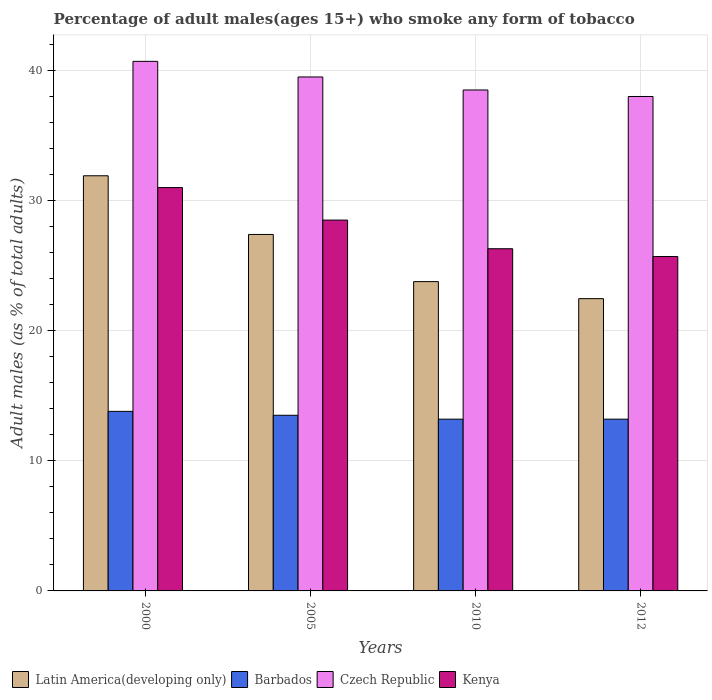Are the number of bars on each tick of the X-axis equal?
Make the answer very short. Yes. What is the label of the 1st group of bars from the left?
Your response must be concise. 2000. In how many cases, is the number of bars for a given year not equal to the number of legend labels?
Offer a very short reply. 0. What is the percentage of adult males who smoke in Latin America(developing only) in 2005?
Keep it short and to the point. 27.4. Across all years, what is the maximum percentage of adult males who smoke in Latin America(developing only)?
Provide a short and direct response. 31.91. Across all years, what is the minimum percentage of adult males who smoke in Kenya?
Make the answer very short. 25.7. In which year was the percentage of adult males who smoke in Latin America(developing only) maximum?
Your answer should be very brief. 2000. What is the total percentage of adult males who smoke in Latin America(developing only) in the graph?
Offer a terse response. 105.54. What is the difference between the percentage of adult males who smoke in Latin America(developing only) in 2000 and that in 2010?
Make the answer very short. 8.13. What is the difference between the percentage of adult males who smoke in Czech Republic in 2000 and the percentage of adult males who smoke in Kenya in 2010?
Your response must be concise. 14.4. What is the average percentage of adult males who smoke in Czech Republic per year?
Your response must be concise. 39.17. In the year 2000, what is the difference between the percentage of adult males who smoke in Czech Republic and percentage of adult males who smoke in Kenya?
Your answer should be very brief. 9.7. In how many years, is the percentage of adult males who smoke in Barbados greater than 36 %?
Provide a short and direct response. 0. What is the ratio of the percentage of adult males who smoke in Barbados in 2005 to that in 2012?
Keep it short and to the point. 1.02. Is the percentage of adult males who smoke in Latin America(developing only) in 2000 less than that in 2012?
Make the answer very short. No. What is the difference between the highest and the second highest percentage of adult males who smoke in Barbados?
Make the answer very short. 0.3. What is the difference between the highest and the lowest percentage of adult males who smoke in Kenya?
Make the answer very short. 5.3. In how many years, is the percentage of adult males who smoke in Barbados greater than the average percentage of adult males who smoke in Barbados taken over all years?
Make the answer very short. 2. Is the sum of the percentage of adult males who smoke in Latin America(developing only) in 2000 and 2005 greater than the maximum percentage of adult males who smoke in Barbados across all years?
Your answer should be compact. Yes. Is it the case that in every year, the sum of the percentage of adult males who smoke in Kenya and percentage of adult males who smoke in Czech Republic is greater than the sum of percentage of adult males who smoke in Barbados and percentage of adult males who smoke in Latin America(developing only)?
Your response must be concise. Yes. What does the 2nd bar from the left in 2005 represents?
Give a very brief answer. Barbados. What does the 2nd bar from the right in 2010 represents?
Provide a short and direct response. Czech Republic. How many bars are there?
Offer a terse response. 16. Are all the bars in the graph horizontal?
Offer a very short reply. No. How many years are there in the graph?
Ensure brevity in your answer.  4. What is the title of the graph?
Give a very brief answer. Percentage of adult males(ages 15+) who smoke any form of tobacco. What is the label or title of the Y-axis?
Give a very brief answer. Adult males (as % of total adults). What is the Adult males (as % of total adults) in Latin America(developing only) in 2000?
Provide a succinct answer. 31.91. What is the Adult males (as % of total adults) in Czech Republic in 2000?
Provide a succinct answer. 40.7. What is the Adult males (as % of total adults) in Latin America(developing only) in 2005?
Offer a very short reply. 27.4. What is the Adult males (as % of total adults) of Barbados in 2005?
Your answer should be compact. 13.5. What is the Adult males (as % of total adults) in Czech Republic in 2005?
Provide a short and direct response. 39.5. What is the Adult males (as % of total adults) of Kenya in 2005?
Provide a succinct answer. 28.5. What is the Adult males (as % of total adults) of Latin America(developing only) in 2010?
Offer a very short reply. 23.77. What is the Adult males (as % of total adults) of Czech Republic in 2010?
Offer a terse response. 38.5. What is the Adult males (as % of total adults) of Kenya in 2010?
Offer a very short reply. 26.3. What is the Adult males (as % of total adults) of Latin America(developing only) in 2012?
Provide a succinct answer. 22.46. What is the Adult males (as % of total adults) in Kenya in 2012?
Your answer should be compact. 25.7. Across all years, what is the maximum Adult males (as % of total adults) of Latin America(developing only)?
Make the answer very short. 31.91. Across all years, what is the maximum Adult males (as % of total adults) of Barbados?
Provide a succinct answer. 13.8. Across all years, what is the maximum Adult males (as % of total adults) of Czech Republic?
Provide a succinct answer. 40.7. Across all years, what is the minimum Adult males (as % of total adults) in Latin America(developing only)?
Keep it short and to the point. 22.46. Across all years, what is the minimum Adult males (as % of total adults) of Kenya?
Your answer should be very brief. 25.7. What is the total Adult males (as % of total adults) in Latin America(developing only) in the graph?
Provide a succinct answer. 105.54. What is the total Adult males (as % of total adults) in Barbados in the graph?
Provide a succinct answer. 53.7. What is the total Adult males (as % of total adults) of Czech Republic in the graph?
Offer a very short reply. 156.7. What is the total Adult males (as % of total adults) in Kenya in the graph?
Give a very brief answer. 111.5. What is the difference between the Adult males (as % of total adults) in Latin America(developing only) in 2000 and that in 2005?
Your answer should be very brief. 4.51. What is the difference between the Adult males (as % of total adults) in Barbados in 2000 and that in 2005?
Make the answer very short. 0.3. What is the difference between the Adult males (as % of total adults) in Kenya in 2000 and that in 2005?
Ensure brevity in your answer.  2.5. What is the difference between the Adult males (as % of total adults) of Latin America(developing only) in 2000 and that in 2010?
Offer a very short reply. 8.13. What is the difference between the Adult males (as % of total adults) of Barbados in 2000 and that in 2010?
Offer a terse response. 0.6. What is the difference between the Adult males (as % of total adults) of Czech Republic in 2000 and that in 2010?
Your response must be concise. 2.2. What is the difference between the Adult males (as % of total adults) of Kenya in 2000 and that in 2010?
Ensure brevity in your answer.  4.7. What is the difference between the Adult males (as % of total adults) in Latin America(developing only) in 2000 and that in 2012?
Offer a terse response. 9.44. What is the difference between the Adult males (as % of total adults) in Latin America(developing only) in 2005 and that in 2010?
Ensure brevity in your answer.  3.62. What is the difference between the Adult males (as % of total adults) of Latin America(developing only) in 2005 and that in 2012?
Ensure brevity in your answer.  4.93. What is the difference between the Adult males (as % of total adults) in Barbados in 2005 and that in 2012?
Ensure brevity in your answer.  0.3. What is the difference between the Adult males (as % of total adults) in Kenya in 2005 and that in 2012?
Your response must be concise. 2.8. What is the difference between the Adult males (as % of total adults) of Latin America(developing only) in 2010 and that in 2012?
Give a very brief answer. 1.31. What is the difference between the Adult males (as % of total adults) in Barbados in 2010 and that in 2012?
Offer a terse response. 0. What is the difference between the Adult males (as % of total adults) of Latin America(developing only) in 2000 and the Adult males (as % of total adults) of Barbados in 2005?
Provide a succinct answer. 18.41. What is the difference between the Adult males (as % of total adults) of Latin America(developing only) in 2000 and the Adult males (as % of total adults) of Czech Republic in 2005?
Make the answer very short. -7.59. What is the difference between the Adult males (as % of total adults) in Latin America(developing only) in 2000 and the Adult males (as % of total adults) in Kenya in 2005?
Your answer should be compact. 3.41. What is the difference between the Adult males (as % of total adults) of Barbados in 2000 and the Adult males (as % of total adults) of Czech Republic in 2005?
Ensure brevity in your answer.  -25.7. What is the difference between the Adult males (as % of total adults) of Barbados in 2000 and the Adult males (as % of total adults) of Kenya in 2005?
Provide a short and direct response. -14.7. What is the difference between the Adult males (as % of total adults) in Czech Republic in 2000 and the Adult males (as % of total adults) in Kenya in 2005?
Keep it short and to the point. 12.2. What is the difference between the Adult males (as % of total adults) of Latin America(developing only) in 2000 and the Adult males (as % of total adults) of Barbados in 2010?
Give a very brief answer. 18.71. What is the difference between the Adult males (as % of total adults) of Latin America(developing only) in 2000 and the Adult males (as % of total adults) of Czech Republic in 2010?
Your response must be concise. -6.59. What is the difference between the Adult males (as % of total adults) of Latin America(developing only) in 2000 and the Adult males (as % of total adults) of Kenya in 2010?
Your answer should be compact. 5.61. What is the difference between the Adult males (as % of total adults) of Barbados in 2000 and the Adult males (as % of total adults) of Czech Republic in 2010?
Your response must be concise. -24.7. What is the difference between the Adult males (as % of total adults) in Barbados in 2000 and the Adult males (as % of total adults) in Kenya in 2010?
Your answer should be very brief. -12.5. What is the difference between the Adult males (as % of total adults) of Czech Republic in 2000 and the Adult males (as % of total adults) of Kenya in 2010?
Offer a terse response. 14.4. What is the difference between the Adult males (as % of total adults) of Latin America(developing only) in 2000 and the Adult males (as % of total adults) of Barbados in 2012?
Your answer should be compact. 18.71. What is the difference between the Adult males (as % of total adults) of Latin America(developing only) in 2000 and the Adult males (as % of total adults) of Czech Republic in 2012?
Keep it short and to the point. -6.09. What is the difference between the Adult males (as % of total adults) in Latin America(developing only) in 2000 and the Adult males (as % of total adults) in Kenya in 2012?
Provide a succinct answer. 6.21. What is the difference between the Adult males (as % of total adults) in Barbados in 2000 and the Adult males (as % of total adults) in Czech Republic in 2012?
Give a very brief answer. -24.2. What is the difference between the Adult males (as % of total adults) in Latin America(developing only) in 2005 and the Adult males (as % of total adults) in Barbados in 2010?
Offer a terse response. 14.2. What is the difference between the Adult males (as % of total adults) in Latin America(developing only) in 2005 and the Adult males (as % of total adults) in Czech Republic in 2010?
Offer a very short reply. -11.1. What is the difference between the Adult males (as % of total adults) of Latin America(developing only) in 2005 and the Adult males (as % of total adults) of Kenya in 2010?
Provide a short and direct response. 1.1. What is the difference between the Adult males (as % of total adults) of Czech Republic in 2005 and the Adult males (as % of total adults) of Kenya in 2010?
Keep it short and to the point. 13.2. What is the difference between the Adult males (as % of total adults) in Latin America(developing only) in 2005 and the Adult males (as % of total adults) in Barbados in 2012?
Give a very brief answer. 14.2. What is the difference between the Adult males (as % of total adults) of Latin America(developing only) in 2005 and the Adult males (as % of total adults) of Czech Republic in 2012?
Your answer should be very brief. -10.6. What is the difference between the Adult males (as % of total adults) in Latin America(developing only) in 2005 and the Adult males (as % of total adults) in Kenya in 2012?
Ensure brevity in your answer.  1.7. What is the difference between the Adult males (as % of total adults) of Barbados in 2005 and the Adult males (as % of total adults) of Czech Republic in 2012?
Make the answer very short. -24.5. What is the difference between the Adult males (as % of total adults) of Barbados in 2005 and the Adult males (as % of total adults) of Kenya in 2012?
Your answer should be very brief. -12.2. What is the difference between the Adult males (as % of total adults) in Czech Republic in 2005 and the Adult males (as % of total adults) in Kenya in 2012?
Your answer should be very brief. 13.8. What is the difference between the Adult males (as % of total adults) of Latin America(developing only) in 2010 and the Adult males (as % of total adults) of Barbados in 2012?
Your answer should be compact. 10.57. What is the difference between the Adult males (as % of total adults) in Latin America(developing only) in 2010 and the Adult males (as % of total adults) in Czech Republic in 2012?
Your answer should be very brief. -14.23. What is the difference between the Adult males (as % of total adults) of Latin America(developing only) in 2010 and the Adult males (as % of total adults) of Kenya in 2012?
Offer a terse response. -1.93. What is the difference between the Adult males (as % of total adults) in Barbados in 2010 and the Adult males (as % of total adults) in Czech Republic in 2012?
Offer a very short reply. -24.8. What is the difference between the Adult males (as % of total adults) in Barbados in 2010 and the Adult males (as % of total adults) in Kenya in 2012?
Your answer should be very brief. -12.5. What is the difference between the Adult males (as % of total adults) of Czech Republic in 2010 and the Adult males (as % of total adults) of Kenya in 2012?
Offer a very short reply. 12.8. What is the average Adult males (as % of total adults) in Latin America(developing only) per year?
Make the answer very short. 26.38. What is the average Adult males (as % of total adults) of Barbados per year?
Give a very brief answer. 13.43. What is the average Adult males (as % of total adults) in Czech Republic per year?
Your answer should be compact. 39.17. What is the average Adult males (as % of total adults) of Kenya per year?
Ensure brevity in your answer.  27.88. In the year 2000, what is the difference between the Adult males (as % of total adults) in Latin America(developing only) and Adult males (as % of total adults) in Barbados?
Offer a very short reply. 18.11. In the year 2000, what is the difference between the Adult males (as % of total adults) in Latin America(developing only) and Adult males (as % of total adults) in Czech Republic?
Your response must be concise. -8.79. In the year 2000, what is the difference between the Adult males (as % of total adults) in Latin America(developing only) and Adult males (as % of total adults) in Kenya?
Offer a very short reply. 0.91. In the year 2000, what is the difference between the Adult males (as % of total adults) in Barbados and Adult males (as % of total adults) in Czech Republic?
Provide a short and direct response. -26.9. In the year 2000, what is the difference between the Adult males (as % of total adults) in Barbados and Adult males (as % of total adults) in Kenya?
Your answer should be very brief. -17.2. In the year 2005, what is the difference between the Adult males (as % of total adults) of Latin America(developing only) and Adult males (as % of total adults) of Barbados?
Offer a terse response. 13.9. In the year 2005, what is the difference between the Adult males (as % of total adults) of Latin America(developing only) and Adult males (as % of total adults) of Czech Republic?
Provide a short and direct response. -12.1. In the year 2005, what is the difference between the Adult males (as % of total adults) of Latin America(developing only) and Adult males (as % of total adults) of Kenya?
Provide a succinct answer. -1.1. In the year 2005, what is the difference between the Adult males (as % of total adults) in Czech Republic and Adult males (as % of total adults) in Kenya?
Your answer should be very brief. 11. In the year 2010, what is the difference between the Adult males (as % of total adults) of Latin America(developing only) and Adult males (as % of total adults) of Barbados?
Your answer should be compact. 10.57. In the year 2010, what is the difference between the Adult males (as % of total adults) in Latin America(developing only) and Adult males (as % of total adults) in Czech Republic?
Your answer should be very brief. -14.73. In the year 2010, what is the difference between the Adult males (as % of total adults) of Latin America(developing only) and Adult males (as % of total adults) of Kenya?
Your answer should be very brief. -2.53. In the year 2010, what is the difference between the Adult males (as % of total adults) in Barbados and Adult males (as % of total adults) in Czech Republic?
Offer a terse response. -25.3. In the year 2010, what is the difference between the Adult males (as % of total adults) in Barbados and Adult males (as % of total adults) in Kenya?
Your answer should be compact. -13.1. In the year 2010, what is the difference between the Adult males (as % of total adults) in Czech Republic and Adult males (as % of total adults) in Kenya?
Make the answer very short. 12.2. In the year 2012, what is the difference between the Adult males (as % of total adults) of Latin America(developing only) and Adult males (as % of total adults) of Barbados?
Your answer should be very brief. 9.26. In the year 2012, what is the difference between the Adult males (as % of total adults) of Latin America(developing only) and Adult males (as % of total adults) of Czech Republic?
Ensure brevity in your answer.  -15.54. In the year 2012, what is the difference between the Adult males (as % of total adults) in Latin America(developing only) and Adult males (as % of total adults) in Kenya?
Provide a short and direct response. -3.24. In the year 2012, what is the difference between the Adult males (as % of total adults) in Barbados and Adult males (as % of total adults) in Czech Republic?
Your answer should be compact. -24.8. What is the ratio of the Adult males (as % of total adults) of Latin America(developing only) in 2000 to that in 2005?
Offer a terse response. 1.16. What is the ratio of the Adult males (as % of total adults) in Barbados in 2000 to that in 2005?
Your response must be concise. 1.02. What is the ratio of the Adult males (as % of total adults) in Czech Republic in 2000 to that in 2005?
Offer a terse response. 1.03. What is the ratio of the Adult males (as % of total adults) of Kenya in 2000 to that in 2005?
Your answer should be compact. 1.09. What is the ratio of the Adult males (as % of total adults) of Latin America(developing only) in 2000 to that in 2010?
Offer a very short reply. 1.34. What is the ratio of the Adult males (as % of total adults) in Barbados in 2000 to that in 2010?
Your answer should be very brief. 1.05. What is the ratio of the Adult males (as % of total adults) of Czech Republic in 2000 to that in 2010?
Offer a very short reply. 1.06. What is the ratio of the Adult males (as % of total adults) in Kenya in 2000 to that in 2010?
Offer a terse response. 1.18. What is the ratio of the Adult males (as % of total adults) of Latin America(developing only) in 2000 to that in 2012?
Keep it short and to the point. 1.42. What is the ratio of the Adult males (as % of total adults) in Barbados in 2000 to that in 2012?
Make the answer very short. 1.05. What is the ratio of the Adult males (as % of total adults) in Czech Republic in 2000 to that in 2012?
Your answer should be compact. 1.07. What is the ratio of the Adult males (as % of total adults) of Kenya in 2000 to that in 2012?
Provide a short and direct response. 1.21. What is the ratio of the Adult males (as % of total adults) in Latin America(developing only) in 2005 to that in 2010?
Your response must be concise. 1.15. What is the ratio of the Adult males (as % of total adults) in Barbados in 2005 to that in 2010?
Give a very brief answer. 1.02. What is the ratio of the Adult males (as % of total adults) in Czech Republic in 2005 to that in 2010?
Provide a succinct answer. 1.03. What is the ratio of the Adult males (as % of total adults) of Kenya in 2005 to that in 2010?
Give a very brief answer. 1.08. What is the ratio of the Adult males (as % of total adults) in Latin America(developing only) in 2005 to that in 2012?
Give a very brief answer. 1.22. What is the ratio of the Adult males (as % of total adults) of Barbados in 2005 to that in 2012?
Offer a very short reply. 1.02. What is the ratio of the Adult males (as % of total adults) in Czech Republic in 2005 to that in 2012?
Your response must be concise. 1.04. What is the ratio of the Adult males (as % of total adults) in Kenya in 2005 to that in 2012?
Provide a succinct answer. 1.11. What is the ratio of the Adult males (as % of total adults) in Latin America(developing only) in 2010 to that in 2012?
Your answer should be very brief. 1.06. What is the ratio of the Adult males (as % of total adults) in Czech Republic in 2010 to that in 2012?
Offer a terse response. 1.01. What is the ratio of the Adult males (as % of total adults) in Kenya in 2010 to that in 2012?
Provide a succinct answer. 1.02. What is the difference between the highest and the second highest Adult males (as % of total adults) in Latin America(developing only)?
Make the answer very short. 4.51. What is the difference between the highest and the second highest Adult males (as % of total adults) of Czech Republic?
Provide a succinct answer. 1.2. What is the difference between the highest and the second highest Adult males (as % of total adults) of Kenya?
Your response must be concise. 2.5. What is the difference between the highest and the lowest Adult males (as % of total adults) of Latin America(developing only)?
Offer a terse response. 9.44. What is the difference between the highest and the lowest Adult males (as % of total adults) of Czech Republic?
Your answer should be compact. 2.7. 